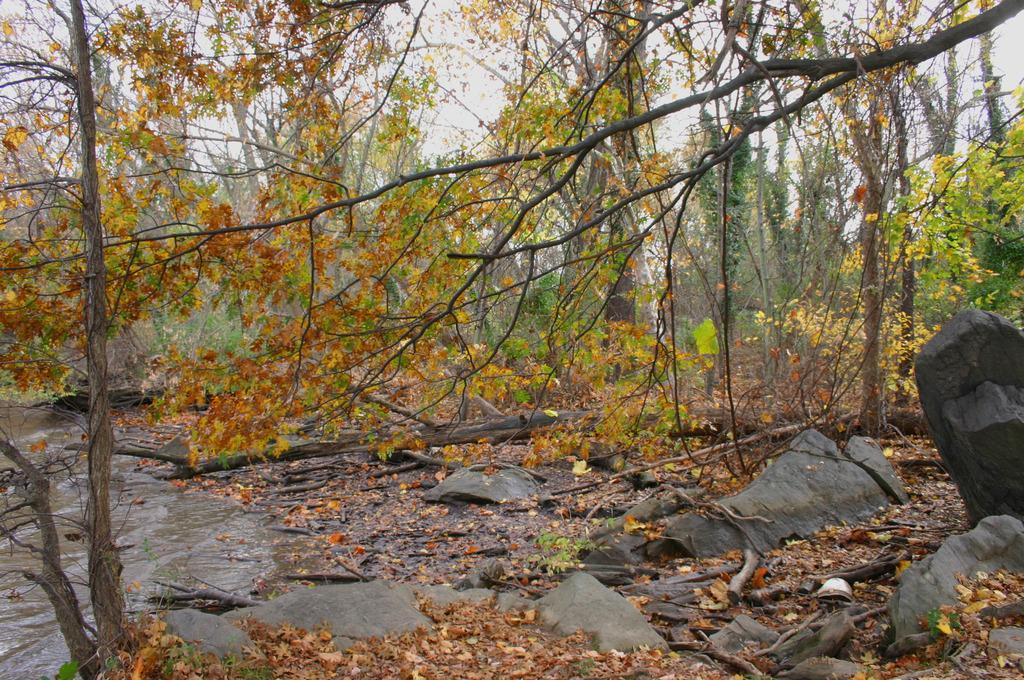Describe this image in one or two sentences. Here in this picture we can see rock stones present on the ground and we can also see dry leaves present and we can also see plants and trees present and on the left side we can see water flowing through the place and we can see the sky is cloudy. 